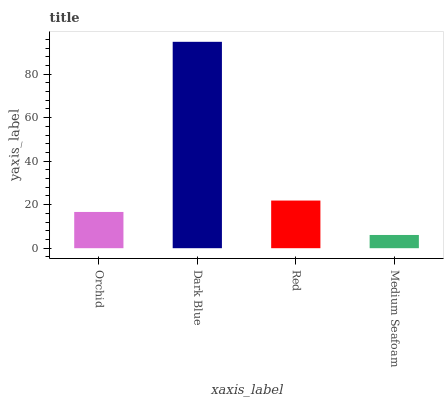Is Medium Seafoam the minimum?
Answer yes or no. Yes. Is Dark Blue the maximum?
Answer yes or no. Yes. Is Red the minimum?
Answer yes or no. No. Is Red the maximum?
Answer yes or no. No. Is Dark Blue greater than Red?
Answer yes or no. Yes. Is Red less than Dark Blue?
Answer yes or no. Yes. Is Red greater than Dark Blue?
Answer yes or no. No. Is Dark Blue less than Red?
Answer yes or no. No. Is Red the high median?
Answer yes or no. Yes. Is Orchid the low median?
Answer yes or no. Yes. Is Medium Seafoam the high median?
Answer yes or no. No. Is Red the low median?
Answer yes or no. No. 